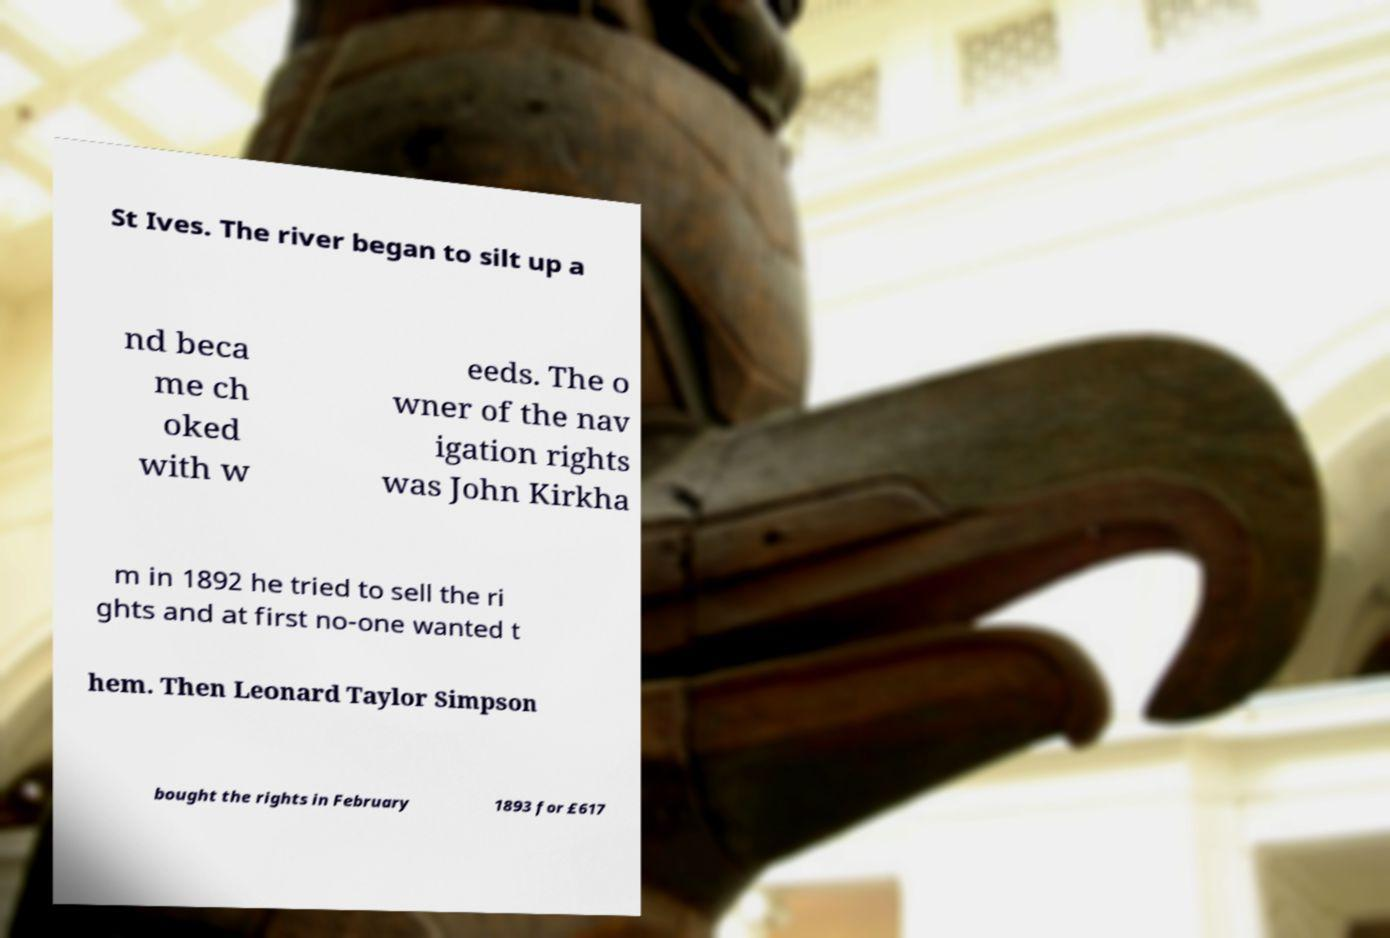I need the written content from this picture converted into text. Can you do that? St Ives. The river began to silt up a nd beca me ch oked with w eeds. The o wner of the nav igation rights was John Kirkha m in 1892 he tried to sell the ri ghts and at first no-one wanted t hem. Then Leonard Taylor Simpson bought the rights in February 1893 for £617 